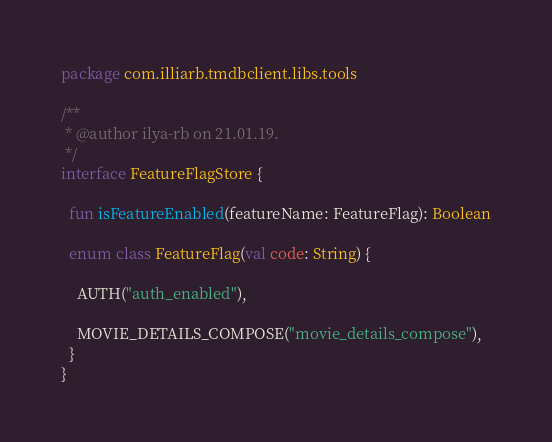Convert code to text. <code><loc_0><loc_0><loc_500><loc_500><_Kotlin_>package com.illiarb.tmdbclient.libs.tools

/**
 * @author ilya-rb on 21.01.19.
 */
interface FeatureFlagStore {

  fun isFeatureEnabled(featureName: FeatureFlag): Boolean

  enum class FeatureFlag(val code: String) {

    AUTH("auth_enabled"),

    MOVIE_DETAILS_COMPOSE("movie_details_compose"),
  }
}
</code> 